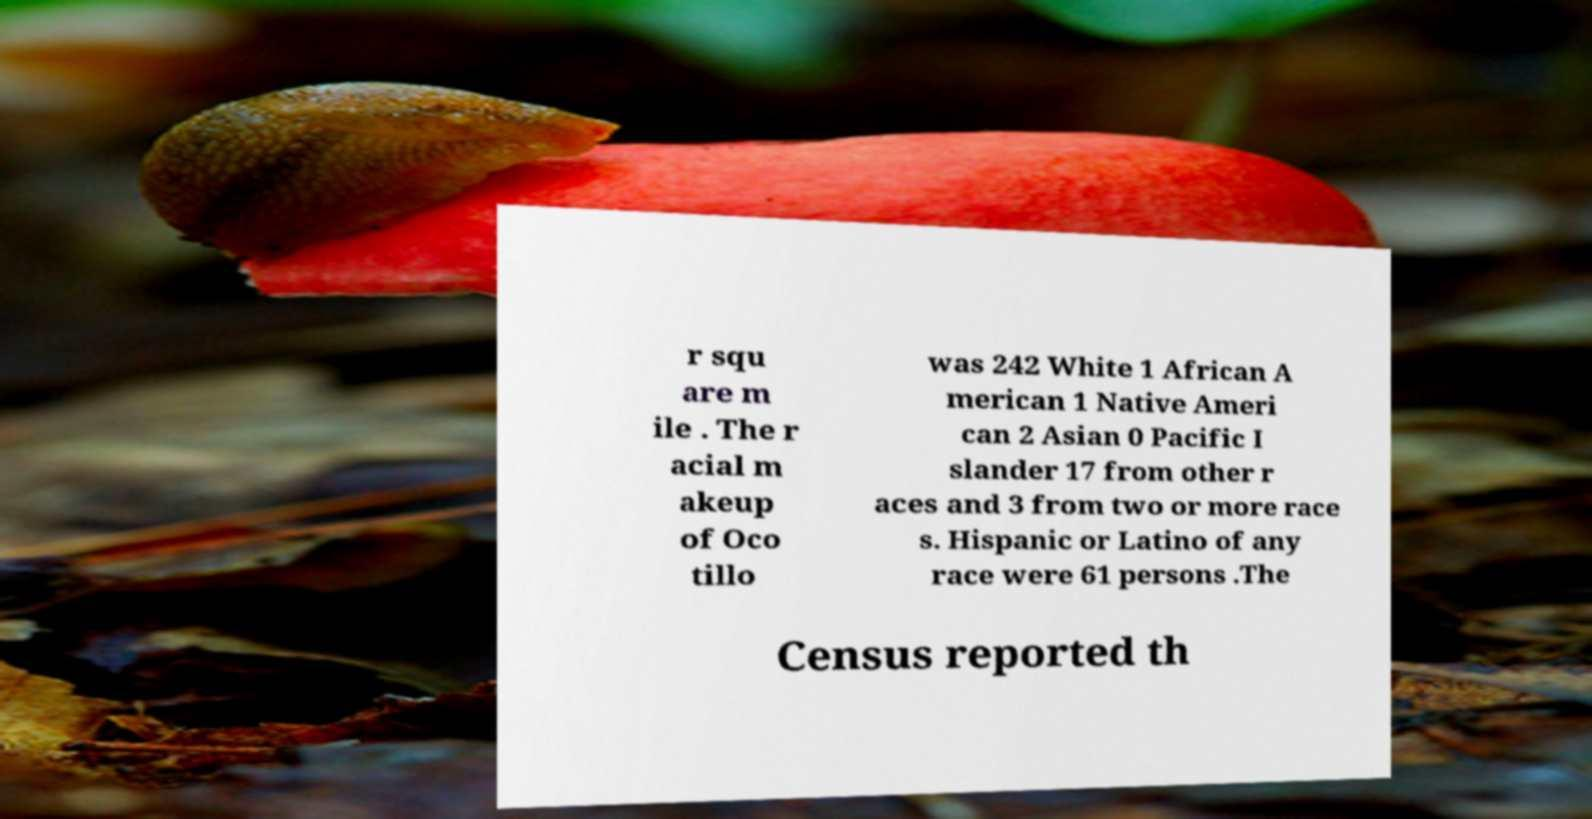There's text embedded in this image that I need extracted. Can you transcribe it verbatim? r squ are m ile . The r acial m akeup of Oco tillo was 242 White 1 African A merican 1 Native Ameri can 2 Asian 0 Pacific I slander 17 from other r aces and 3 from two or more race s. Hispanic or Latino of any race were 61 persons .The Census reported th 